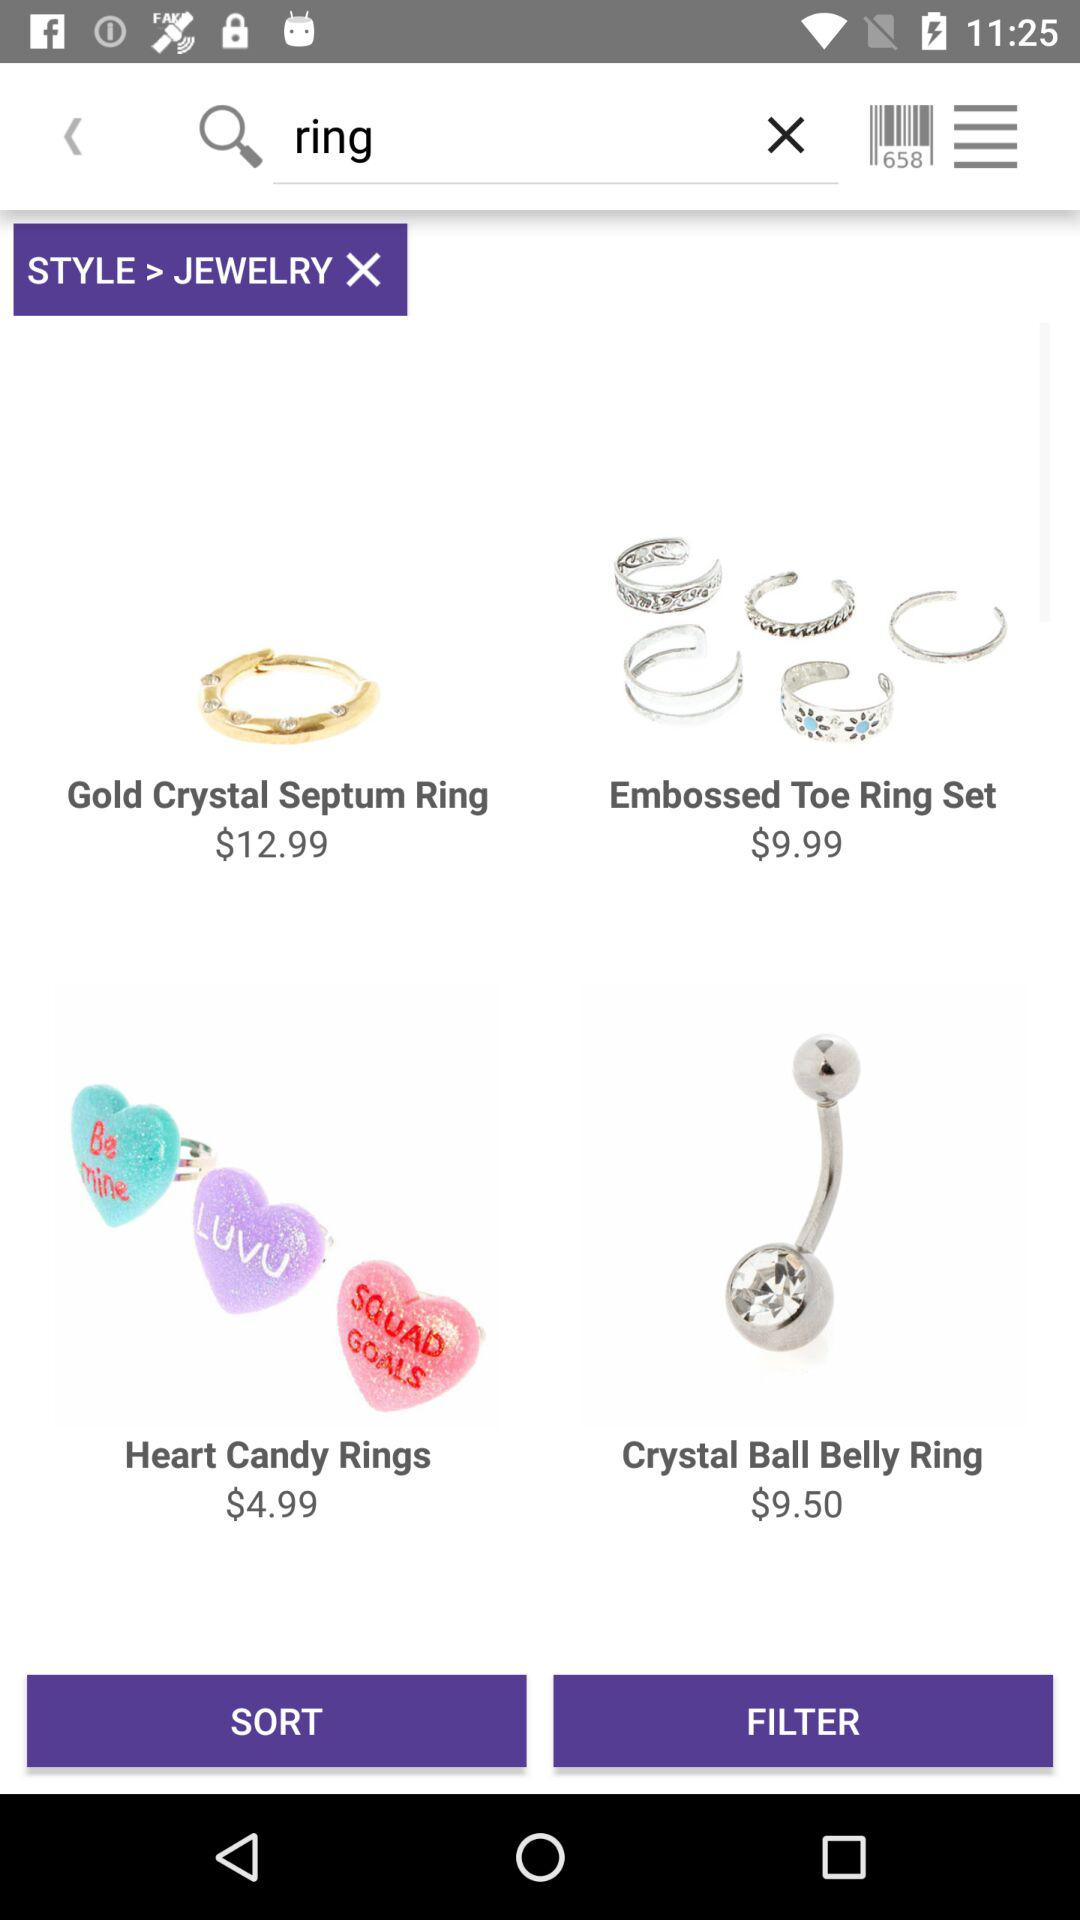What is the price of the "Crystal Ball Belly Ring"? The price of the "Crystal Ball Belly Ring" is $9.50. 